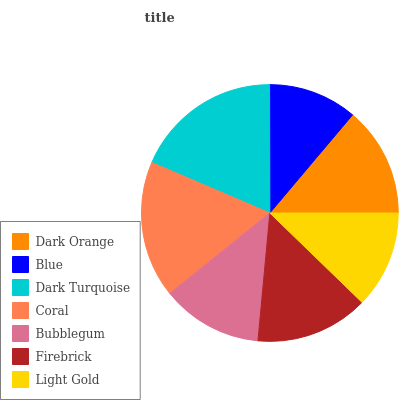Is Blue the minimum?
Answer yes or no. Yes. Is Dark Turquoise the maximum?
Answer yes or no. Yes. Is Dark Turquoise the minimum?
Answer yes or no. No. Is Blue the maximum?
Answer yes or no. No. Is Dark Turquoise greater than Blue?
Answer yes or no. Yes. Is Blue less than Dark Turquoise?
Answer yes or no. Yes. Is Blue greater than Dark Turquoise?
Answer yes or no. No. Is Dark Turquoise less than Blue?
Answer yes or no. No. Is Dark Orange the high median?
Answer yes or no. Yes. Is Dark Orange the low median?
Answer yes or no. Yes. Is Light Gold the high median?
Answer yes or no. No. Is Coral the low median?
Answer yes or no. No. 